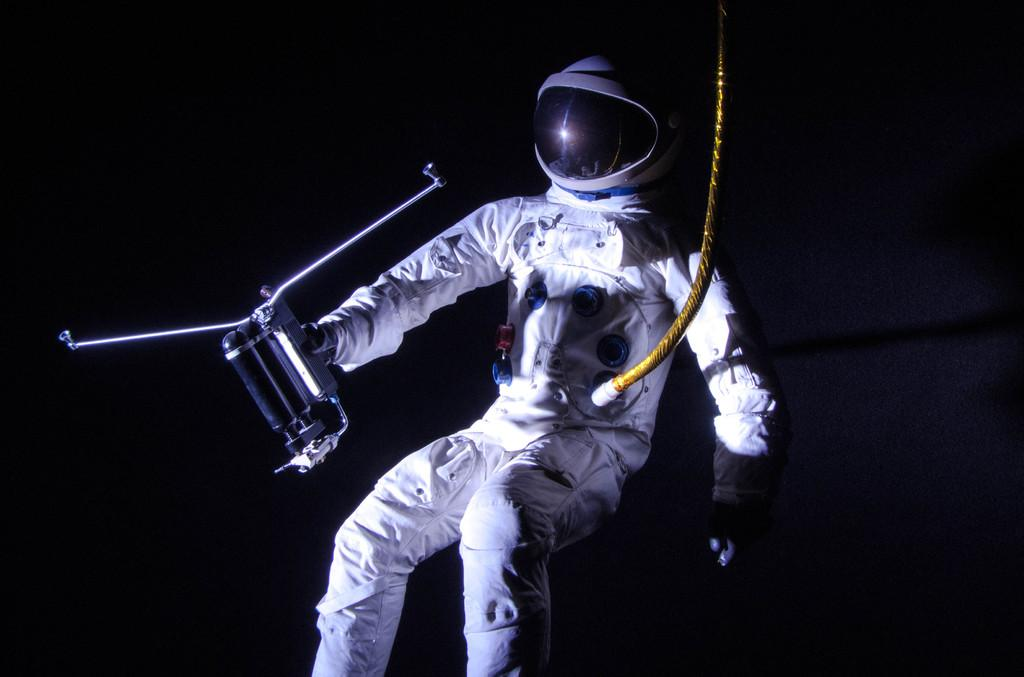What is the main subject of the image? There is an astronaut in the image. What is the astronaut holding in his hand? The astronaut is holding an object in his hand. Can you describe any additional features of the astronaut's equipment? There is a rope connected to the astronaut's spacesuit. What time of day is it in the image, and what type of kettle is visible? The time of day cannot be determined from the image, and there is no kettle present. Can you describe the astronaut's arm and its functionality in the image? The astronaut's arm is part of his spacesuit and is not a separate object with its own functionality in the image. 